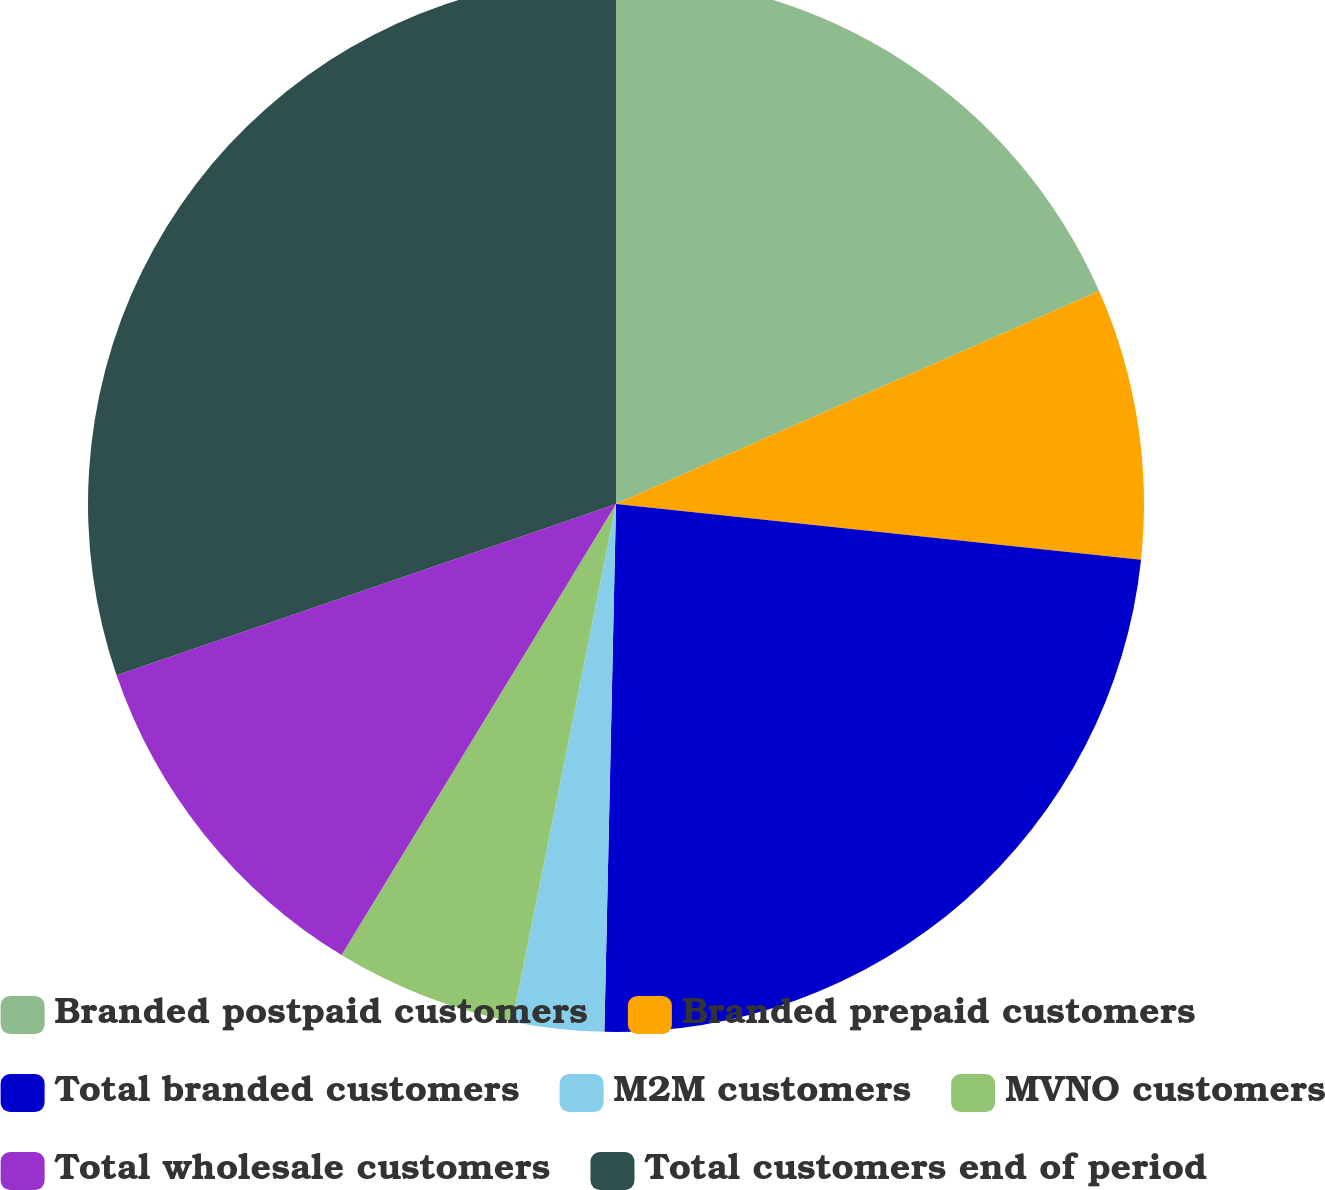<chart> <loc_0><loc_0><loc_500><loc_500><pie_chart><fcel>Branded postpaid customers<fcel>Branded prepaid customers<fcel>Total branded customers<fcel>M2M customers<fcel>MVNO customers<fcel>Total wholesale customers<fcel>Total customers end of period<nl><fcel>18.39%<fcel>8.29%<fcel>23.67%<fcel>2.8%<fcel>5.55%<fcel>11.04%<fcel>30.26%<nl></chart> 